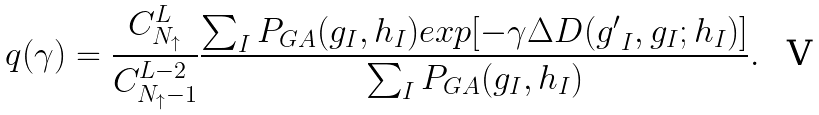<formula> <loc_0><loc_0><loc_500><loc_500>q ( \gamma ) = \frac { C ^ { L } _ { N _ { \uparrow } } } { C ^ { L - 2 } _ { { N _ { \uparrow } } - 1 } } \frac { \sum _ { I } P _ { G A } ( { g } _ { I } , { h } _ { I } ) e x p [ - \gamma \Delta D ( { g ^ { \prime } } _ { I } , { g } _ { I } ; { h } _ { I } ) ] } { \sum _ { I } P _ { G A } ( { g } _ { I } , { h } _ { I } ) } .</formula> 